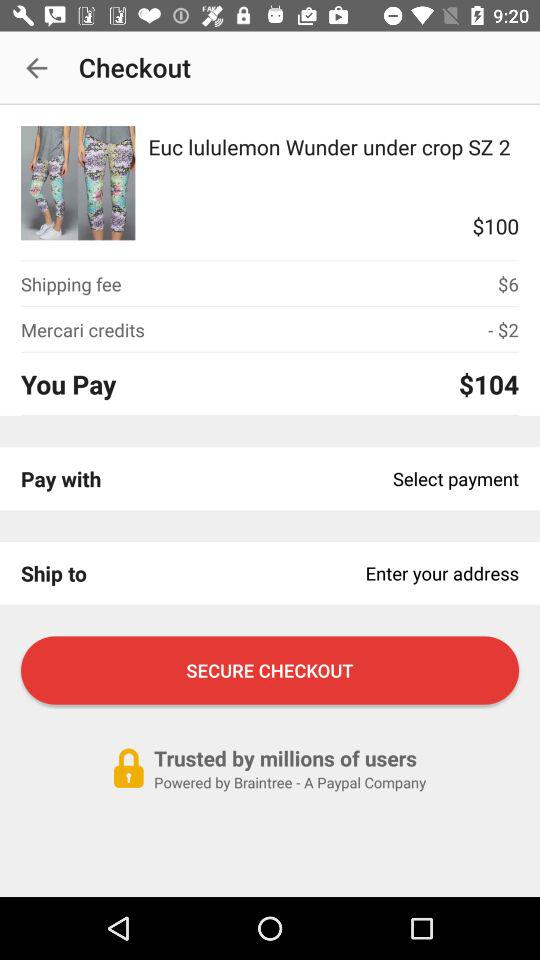What is the name of the product? The name of the product is "Euc lululemon Wunder under crop SZ 2". 